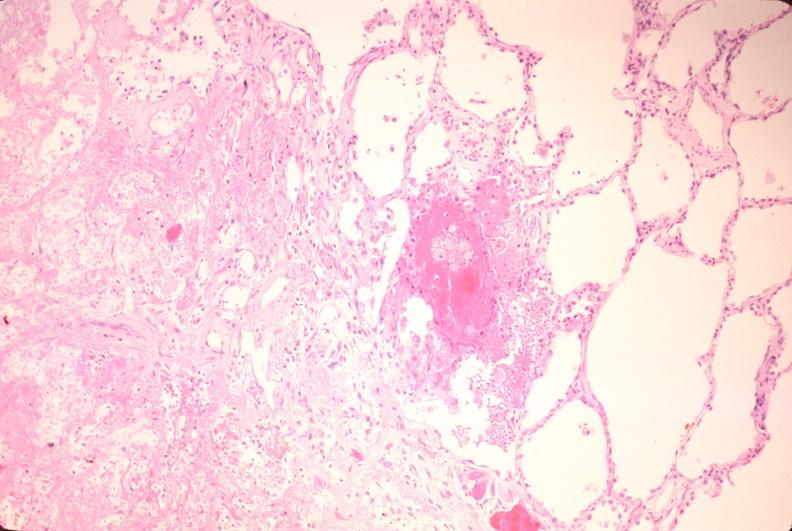s chordoma present?
Answer the question using a single word or phrase. No 